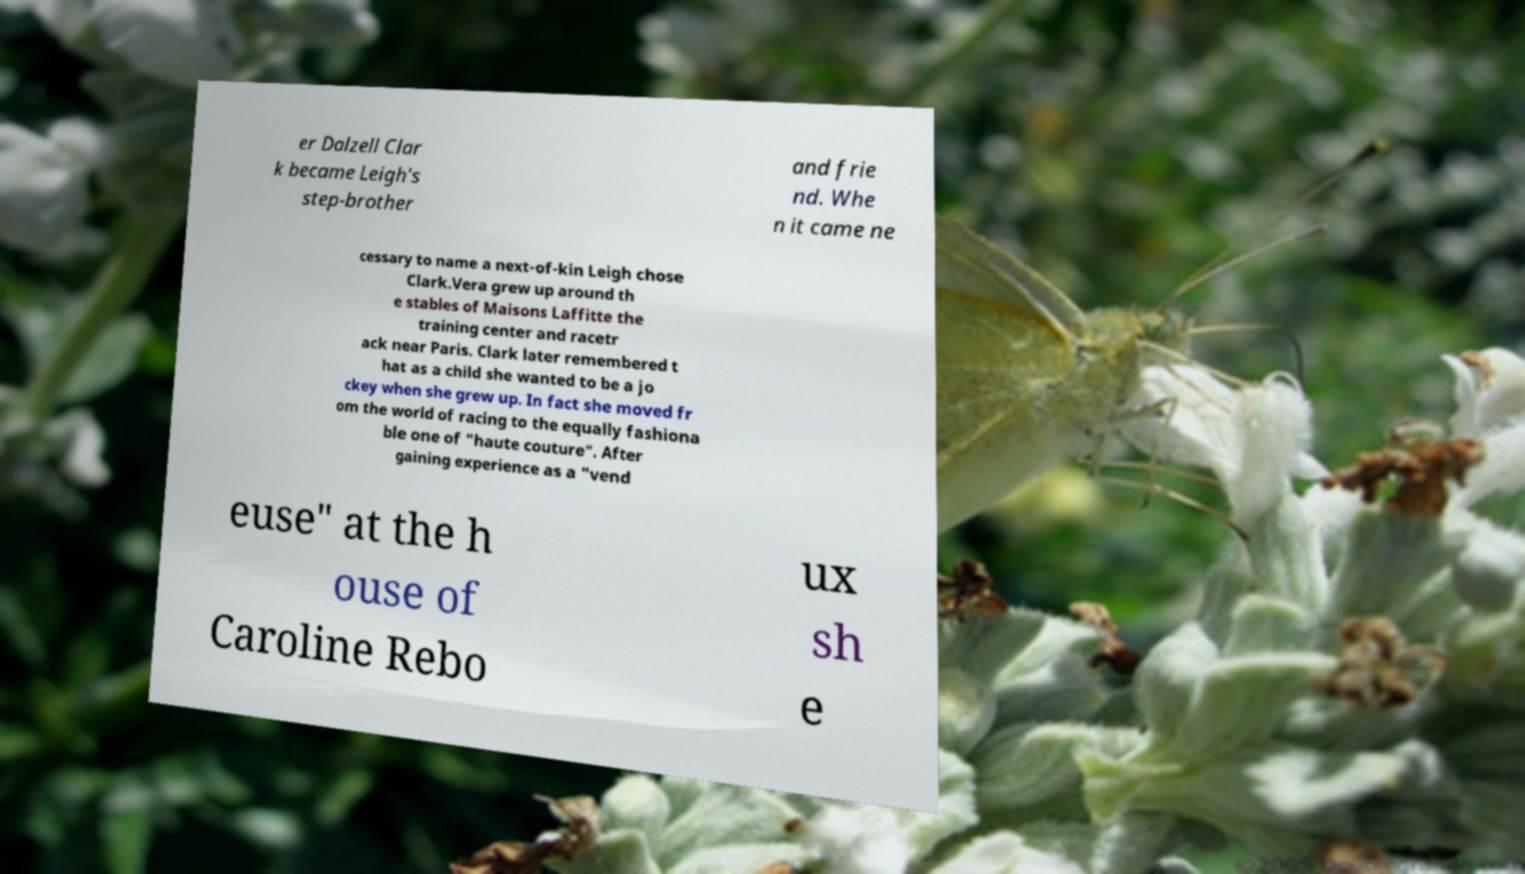For documentation purposes, I need the text within this image transcribed. Could you provide that? er Dalzell Clar k became Leigh's step-brother and frie nd. Whe n it came ne cessary to name a next-of-kin Leigh chose Clark.Vera grew up around th e stables of Maisons Laffitte the training center and racetr ack near Paris. Clark later remembered t hat as a child she wanted to be a jo ckey when she grew up. In fact she moved fr om the world of racing to the equally fashiona ble one of "haute couture". After gaining experience as a "vend euse" at the h ouse of Caroline Rebo ux sh e 